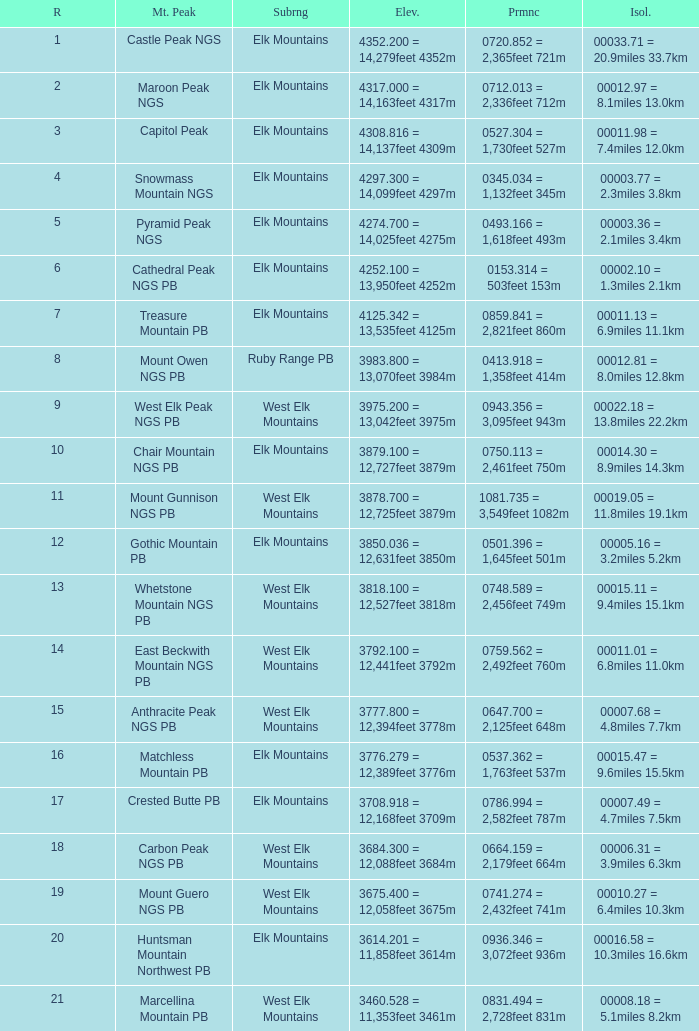Could you parse the entire table? {'header': ['R', 'Mt. Peak', 'Subrng', 'Elev.', 'Prmnc', 'Isol.'], 'rows': [['1', 'Castle Peak NGS', 'Elk Mountains', '4352.200 = 14,279feet 4352m', '0720.852 = 2,365feet 721m', '00033.71 = 20.9miles 33.7km'], ['2', 'Maroon Peak NGS', 'Elk Mountains', '4317.000 = 14,163feet 4317m', '0712.013 = 2,336feet 712m', '00012.97 = 8.1miles 13.0km'], ['3', 'Capitol Peak', 'Elk Mountains', '4308.816 = 14,137feet 4309m', '0527.304 = 1,730feet 527m', '00011.98 = 7.4miles 12.0km'], ['4', 'Snowmass Mountain NGS', 'Elk Mountains', '4297.300 = 14,099feet 4297m', '0345.034 = 1,132feet 345m', '00003.77 = 2.3miles 3.8km'], ['5', 'Pyramid Peak NGS', 'Elk Mountains', '4274.700 = 14,025feet 4275m', '0493.166 = 1,618feet 493m', '00003.36 = 2.1miles 3.4km'], ['6', 'Cathedral Peak NGS PB', 'Elk Mountains', '4252.100 = 13,950feet 4252m', '0153.314 = 503feet 153m', '00002.10 = 1.3miles 2.1km'], ['7', 'Treasure Mountain PB', 'Elk Mountains', '4125.342 = 13,535feet 4125m', '0859.841 = 2,821feet 860m', '00011.13 = 6.9miles 11.1km'], ['8', 'Mount Owen NGS PB', 'Ruby Range PB', '3983.800 = 13,070feet 3984m', '0413.918 = 1,358feet 414m', '00012.81 = 8.0miles 12.8km'], ['9', 'West Elk Peak NGS PB', 'West Elk Mountains', '3975.200 = 13,042feet 3975m', '0943.356 = 3,095feet 943m', '00022.18 = 13.8miles 22.2km'], ['10', 'Chair Mountain NGS PB', 'Elk Mountains', '3879.100 = 12,727feet 3879m', '0750.113 = 2,461feet 750m', '00014.30 = 8.9miles 14.3km'], ['11', 'Mount Gunnison NGS PB', 'West Elk Mountains', '3878.700 = 12,725feet 3879m', '1081.735 = 3,549feet 1082m', '00019.05 = 11.8miles 19.1km'], ['12', 'Gothic Mountain PB', 'Elk Mountains', '3850.036 = 12,631feet 3850m', '0501.396 = 1,645feet 501m', '00005.16 = 3.2miles 5.2km'], ['13', 'Whetstone Mountain NGS PB', 'West Elk Mountains', '3818.100 = 12,527feet 3818m', '0748.589 = 2,456feet 749m', '00015.11 = 9.4miles 15.1km'], ['14', 'East Beckwith Mountain NGS PB', 'West Elk Mountains', '3792.100 = 12,441feet 3792m', '0759.562 = 2,492feet 760m', '00011.01 = 6.8miles 11.0km'], ['15', 'Anthracite Peak NGS PB', 'West Elk Mountains', '3777.800 = 12,394feet 3778m', '0647.700 = 2,125feet 648m', '00007.68 = 4.8miles 7.7km'], ['16', 'Matchless Mountain PB', 'Elk Mountains', '3776.279 = 12,389feet 3776m', '0537.362 = 1,763feet 537m', '00015.47 = 9.6miles 15.5km'], ['17', 'Crested Butte PB', 'Elk Mountains', '3708.918 = 12,168feet 3709m', '0786.994 = 2,582feet 787m', '00007.49 = 4.7miles 7.5km'], ['18', 'Carbon Peak NGS PB', 'West Elk Mountains', '3684.300 = 12,088feet 3684m', '0664.159 = 2,179feet 664m', '00006.31 = 3.9miles 6.3km'], ['19', 'Mount Guero NGS PB', 'West Elk Mountains', '3675.400 = 12,058feet 3675m', '0741.274 = 2,432feet 741m', '00010.27 = 6.4miles 10.3km'], ['20', 'Huntsman Mountain Northwest PB', 'Elk Mountains', '3614.201 = 11,858feet 3614m', '0936.346 = 3,072feet 936m', '00016.58 = 10.3miles 16.6km'], ['21', 'Marcellina Mountain PB', 'West Elk Mountains', '3460.528 = 11,353feet 3461m', '0831.494 = 2,728feet 831m', '00008.18 = 5.1miles 8.2km']]} Name the Rank of Rank Mountain Peak of crested butte pb? 17.0. 